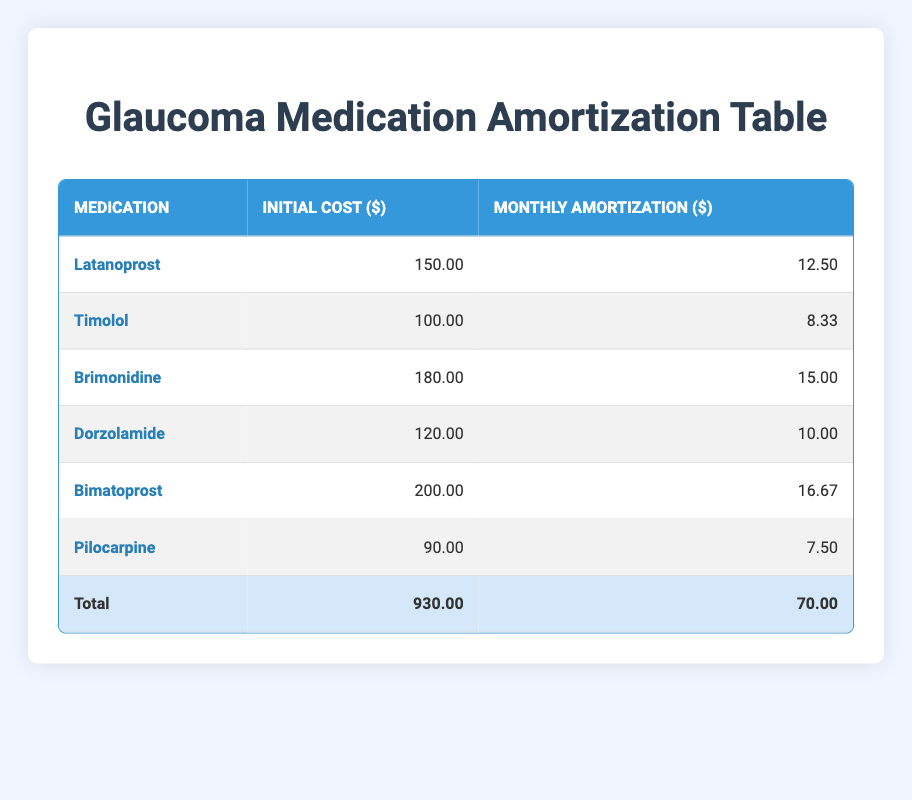What is the initial cost of Brimonidine? The initial cost of Brimonidine is listed in the second column of the table under its corresponding row, which shows the value of 180.00.
Answer: 180.00 How much is the monthly amortization cost for Latanoprost? The monthly amortization cost for Latanoprost can be found in the third column of the table, where it lists the amount as 12.50.
Answer: 12.50 What is the total initial cost of all the medications combined? The total initial cost is provided in the last row of the table, which sums up the initial costs for all medications and is specified as 930.00.
Answer: 930.00 Is the monthly amortization for Timolol greater than the monthly amortization for Pilocarpine? The values for Timolol and Pilocarpine are compared: Timolol's monthly amortization is 8.33, while Pilocarpine's is 7.50. Since 8.33 is greater than 7.50, the statement is true.
Answer: Yes What is the average monthly amortization of the glaucoma medications? First, the total monthly amortization is noted as 70.00 from the final row. There are 6 medications, so the average is calculated by dividing 70.00 by 6, which results in approximately 11.67.
Answer: 11.67 How much more is the monthly amortization of Bimatoprost compared to Timolol? Bimatoprost’s monthly amortization is 16.67 and Timolol’s is 8.33. To find the difference, subtract 8.33 from 16.67, resulting in 8.34.
Answer: 8.34 Is the total monthly amortization cost of all medications equal to 80.00? The total monthly amortization is provided in the last row of the table as 70.00, which shows that 70.00 does not equal 80.00. Therefore, the statement is false.
Answer: No Which medication has the highest monthly amortization? By examining the third column, Bimatoprost has the highest monthly amortization value of 16.67 compared to all other medications listed.
Answer: Bimatoprost 